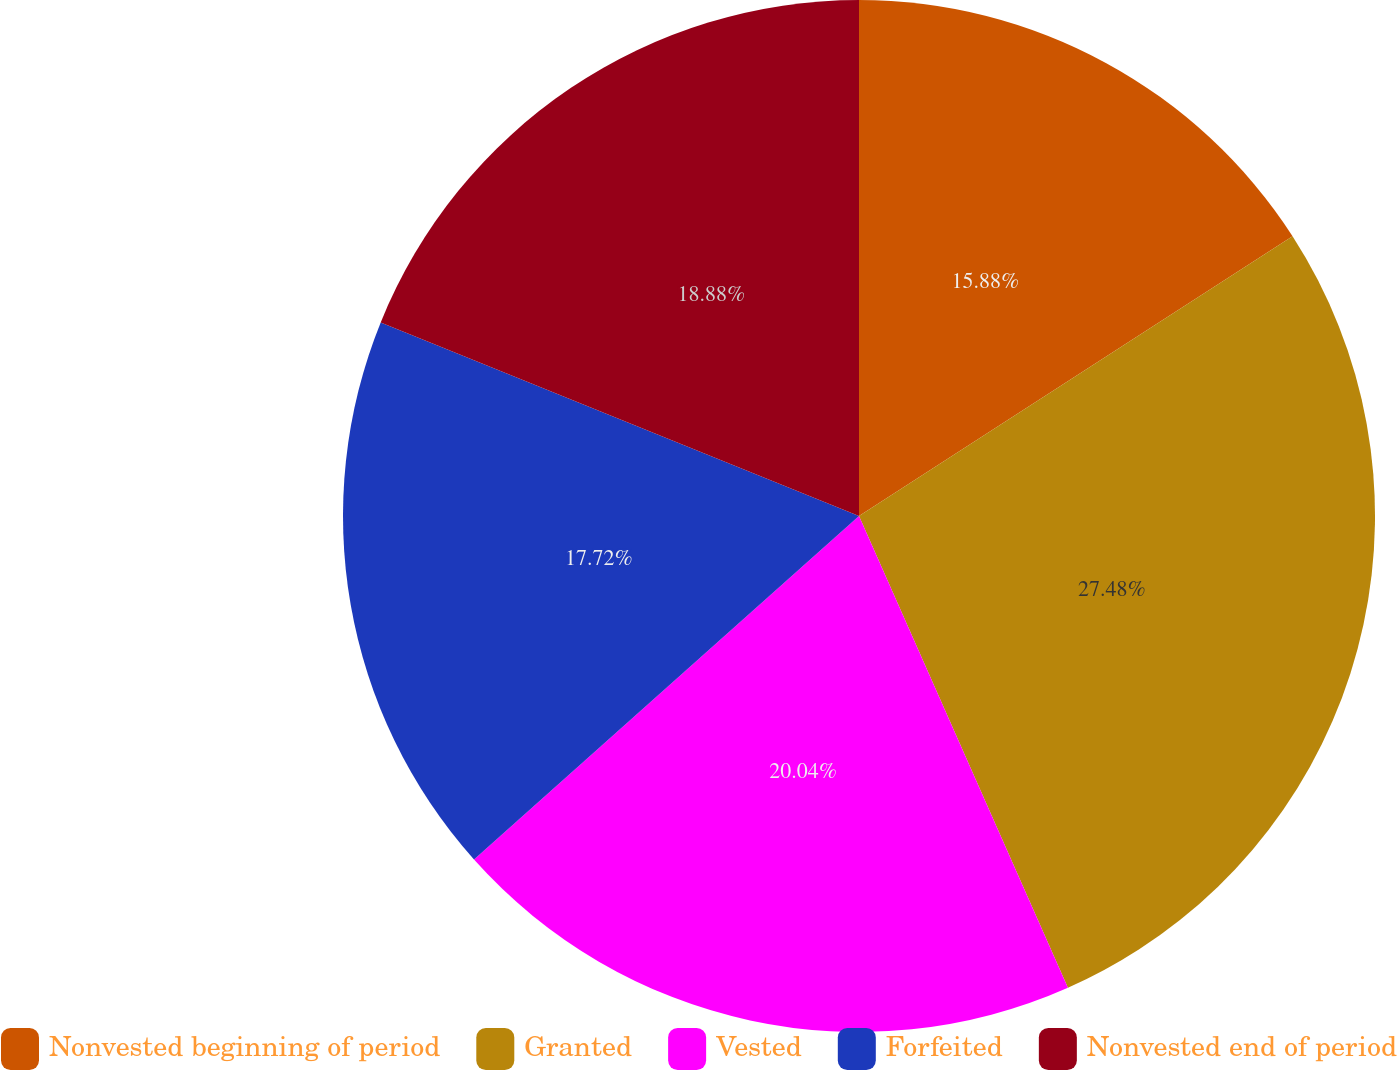Convert chart to OTSL. <chart><loc_0><loc_0><loc_500><loc_500><pie_chart><fcel>Nonvested beginning of period<fcel>Granted<fcel>Vested<fcel>Forfeited<fcel>Nonvested end of period<nl><fcel>15.88%<fcel>27.49%<fcel>20.04%<fcel>17.72%<fcel>18.88%<nl></chart> 